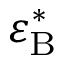Convert formula to latex. <formula><loc_0><loc_0><loc_500><loc_500>\varepsilon _ { B } ^ { \ast }</formula> 